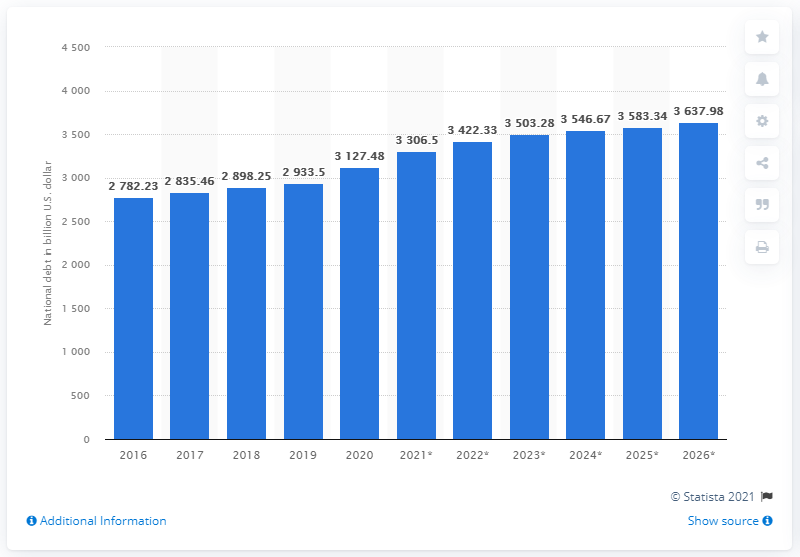Indicate a few pertinent items in this graphic. As of 2020, Italy's national debt has come to an end. The national debt of Italy in dollars in 2020 was 3127.48... As of 2020, Italy's national debt has come to an end. 